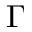<formula> <loc_0><loc_0><loc_500><loc_500>\Gamma</formula> 